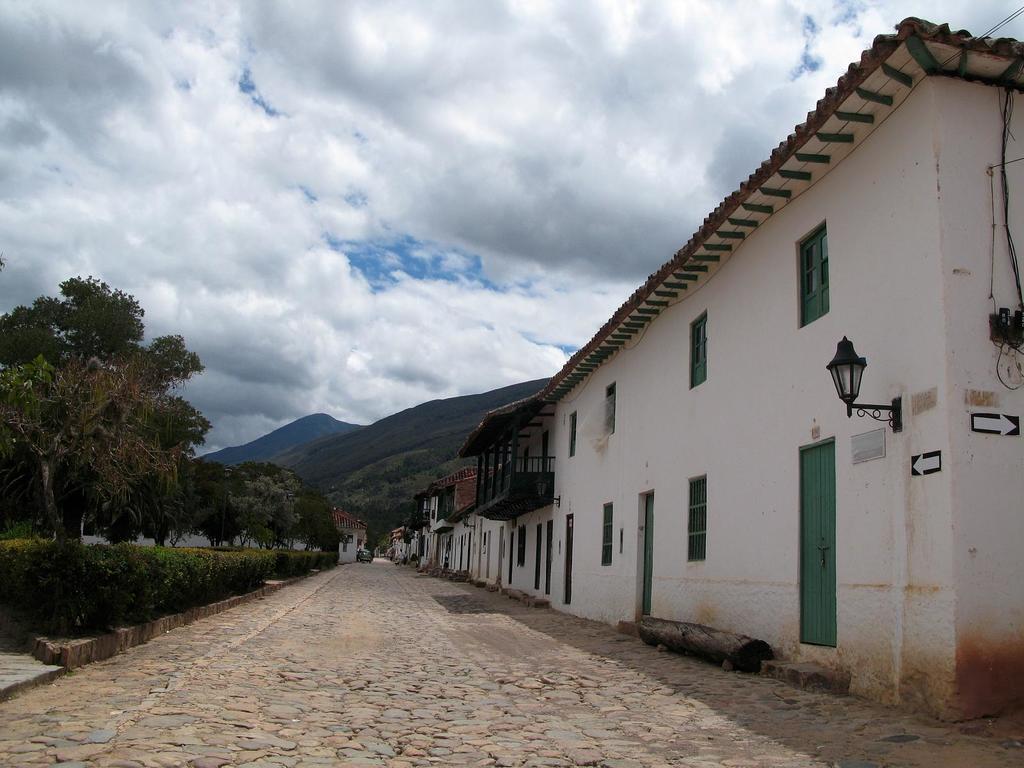Could you give a brief overview of what you see in this image? In the middle of the image we can see some buildings and trees and plants. Behind the buildings there are some hills. At the top of the image there are some clouds and sky. 